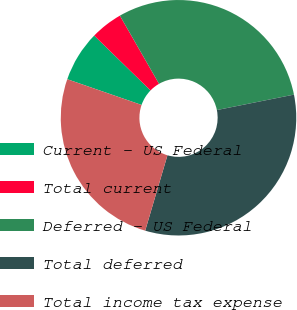<chart> <loc_0><loc_0><loc_500><loc_500><pie_chart><fcel>Current - US Federal<fcel>Total current<fcel>Deferred - US Federal<fcel>Total deferred<fcel>Total income tax expense<nl><fcel>6.99%<fcel>4.41%<fcel>30.15%<fcel>32.72%<fcel>25.74%<nl></chart> 